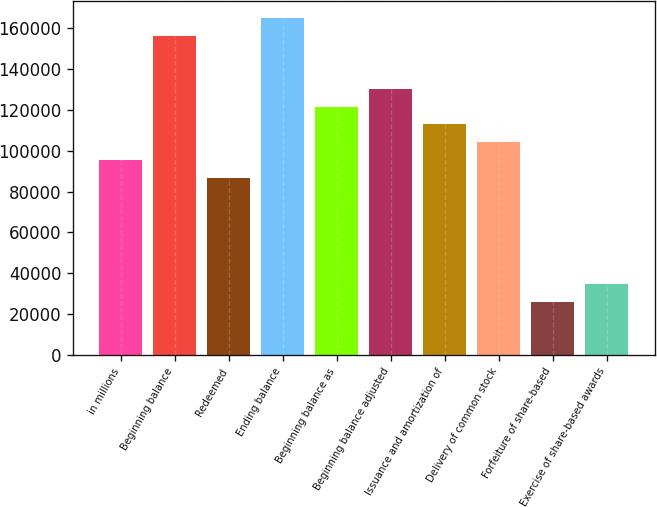Convert chart to OTSL. <chart><loc_0><loc_0><loc_500><loc_500><bar_chart><fcel>in millions<fcel>Beginning balance<fcel>Redeemed<fcel>Ending balance<fcel>Beginning balance as<fcel>Beginning balance adjusted<fcel>Issuance and amortization of<fcel>Delivery of common stock<fcel>Forfeiture of share-based<fcel>Exercise of share-based awards<nl><fcel>95581.6<fcel>156402<fcel>86893<fcel>165090<fcel>121647<fcel>130336<fcel>112959<fcel>104270<fcel>26072.8<fcel>34761.4<nl></chart> 